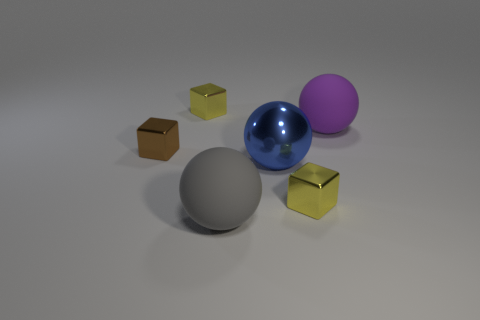What is the tiny object that is behind the purple thing made of?
Offer a very short reply. Metal. Is the size of the brown block the same as the gray ball?
Provide a succinct answer. No. The thing that is right of the large blue shiny sphere and in front of the blue ball is what color?
Provide a short and direct response. Yellow. There is a small brown object that is the same material as the blue thing; what is its shape?
Offer a terse response. Cube. How many yellow objects are both behind the brown metallic block and in front of the big blue ball?
Provide a short and direct response. 0. Are there any spheres behind the blue object?
Provide a short and direct response. Yes. There is a gray object that is in front of the blue metallic ball; is its shape the same as the yellow shiny thing that is behind the large purple object?
Offer a terse response. No. How many objects are either small brown blocks or large rubber balls that are in front of the big metallic ball?
Your response must be concise. 2. How many other objects are there of the same shape as the purple matte object?
Make the answer very short. 2. Is the tiny block on the right side of the large gray rubber ball made of the same material as the purple object?
Keep it short and to the point. No. 